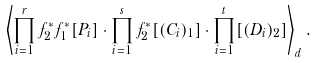<formula> <loc_0><loc_0><loc_500><loc_500>\left \langle \prod _ { i = 1 } ^ { r } f _ { 2 } ^ { * } f _ { 1 } ^ { * } [ P _ { i } ] \cdot \prod _ { i = 1 } ^ { s } f _ { 2 } ^ { * } [ ( C _ { i } ) _ { 1 } ] \cdot \prod _ { i = 1 } ^ { t } [ ( D _ { i } ) _ { 2 } ] \right \rangle _ { d } .</formula> 